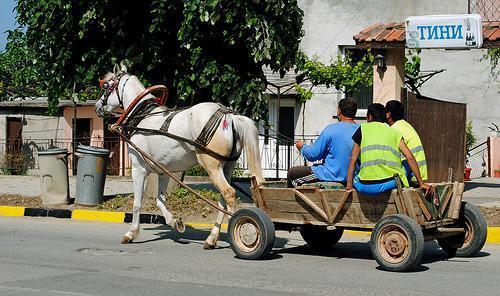How many men are in the cart?
Give a very brief answer. 3. 